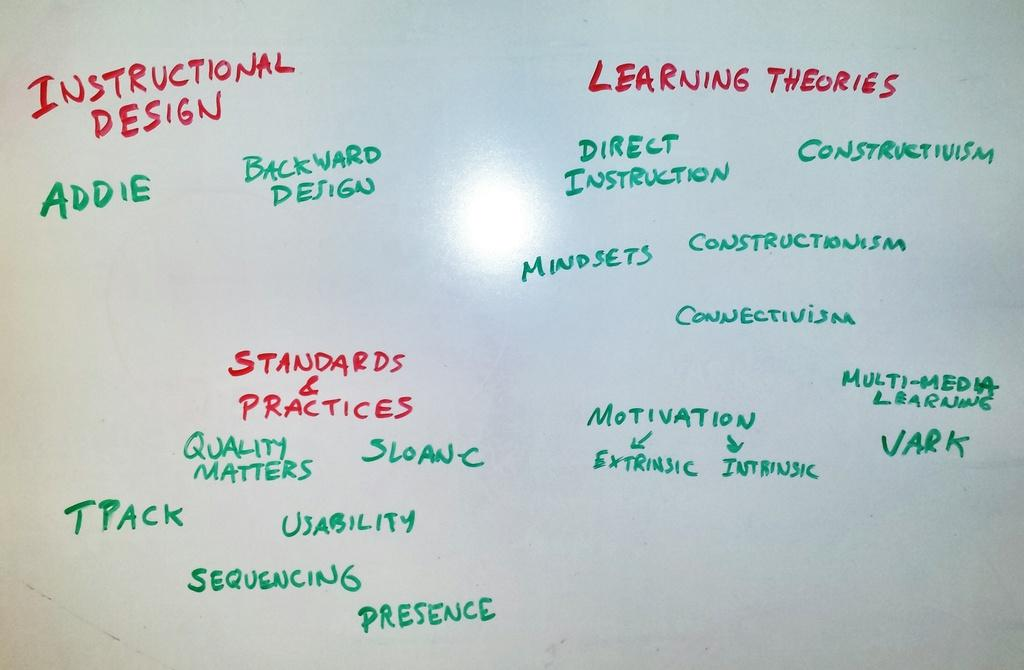Provide a one-sentence caption for the provided image. A list of learning theories written on a white board. 